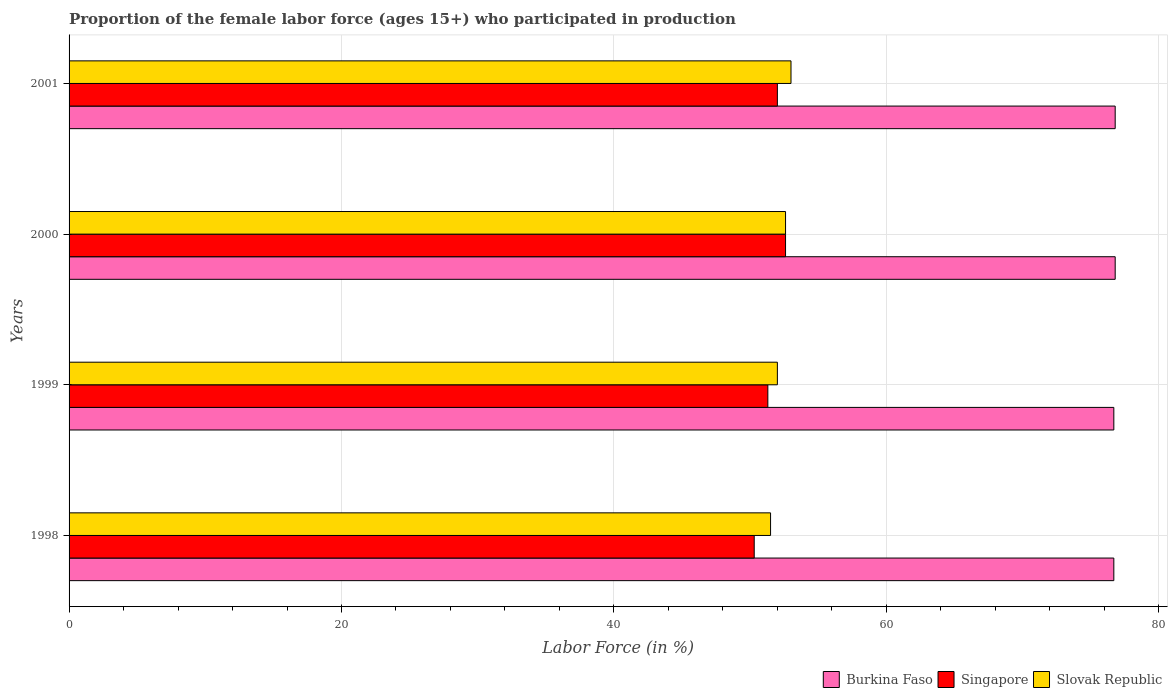How many groups of bars are there?
Your answer should be very brief. 4. Are the number of bars per tick equal to the number of legend labels?
Ensure brevity in your answer.  Yes. Are the number of bars on each tick of the Y-axis equal?
Offer a terse response. Yes. What is the proportion of the female labor force who participated in production in Singapore in 1999?
Provide a succinct answer. 51.3. Across all years, what is the maximum proportion of the female labor force who participated in production in Burkina Faso?
Give a very brief answer. 76.8. Across all years, what is the minimum proportion of the female labor force who participated in production in Singapore?
Ensure brevity in your answer.  50.3. What is the total proportion of the female labor force who participated in production in Singapore in the graph?
Keep it short and to the point. 206.2. What is the difference between the proportion of the female labor force who participated in production in Slovak Republic in 1998 and that in 2000?
Your answer should be compact. -1.1. What is the difference between the proportion of the female labor force who participated in production in Singapore in 2000 and the proportion of the female labor force who participated in production in Burkina Faso in 1999?
Your answer should be very brief. -24.1. What is the average proportion of the female labor force who participated in production in Slovak Republic per year?
Provide a short and direct response. 52.27. In the year 2001, what is the difference between the proportion of the female labor force who participated in production in Slovak Republic and proportion of the female labor force who participated in production in Burkina Faso?
Your response must be concise. -23.8. In how many years, is the proportion of the female labor force who participated in production in Burkina Faso greater than 60 %?
Give a very brief answer. 4. What is the ratio of the proportion of the female labor force who participated in production in Singapore in 2000 to that in 2001?
Ensure brevity in your answer.  1.01. Is the proportion of the female labor force who participated in production in Singapore in 1998 less than that in 2000?
Ensure brevity in your answer.  Yes. Is the difference between the proportion of the female labor force who participated in production in Slovak Republic in 1999 and 2000 greater than the difference between the proportion of the female labor force who participated in production in Burkina Faso in 1999 and 2000?
Provide a short and direct response. No. What is the difference between the highest and the second highest proportion of the female labor force who participated in production in Singapore?
Offer a terse response. 0.6. What is the difference between the highest and the lowest proportion of the female labor force who participated in production in Burkina Faso?
Keep it short and to the point. 0.1. In how many years, is the proportion of the female labor force who participated in production in Singapore greater than the average proportion of the female labor force who participated in production in Singapore taken over all years?
Ensure brevity in your answer.  2. What does the 1st bar from the top in 1998 represents?
Keep it short and to the point. Slovak Republic. What does the 3rd bar from the bottom in 2000 represents?
Offer a terse response. Slovak Republic. How many bars are there?
Your answer should be very brief. 12. Are all the bars in the graph horizontal?
Keep it short and to the point. Yes. What is the difference between two consecutive major ticks on the X-axis?
Your answer should be compact. 20. Are the values on the major ticks of X-axis written in scientific E-notation?
Offer a terse response. No. Does the graph contain any zero values?
Keep it short and to the point. No. Where does the legend appear in the graph?
Offer a very short reply. Bottom right. What is the title of the graph?
Keep it short and to the point. Proportion of the female labor force (ages 15+) who participated in production. Does "Kyrgyz Republic" appear as one of the legend labels in the graph?
Your answer should be compact. No. What is the Labor Force (in %) of Burkina Faso in 1998?
Make the answer very short. 76.7. What is the Labor Force (in %) of Singapore in 1998?
Give a very brief answer. 50.3. What is the Labor Force (in %) in Slovak Republic in 1998?
Your answer should be very brief. 51.5. What is the Labor Force (in %) of Burkina Faso in 1999?
Offer a terse response. 76.7. What is the Labor Force (in %) of Singapore in 1999?
Provide a succinct answer. 51.3. What is the Labor Force (in %) in Burkina Faso in 2000?
Provide a succinct answer. 76.8. What is the Labor Force (in %) of Singapore in 2000?
Give a very brief answer. 52.6. What is the Labor Force (in %) in Slovak Republic in 2000?
Offer a terse response. 52.6. What is the Labor Force (in %) in Burkina Faso in 2001?
Offer a very short reply. 76.8. What is the Labor Force (in %) of Singapore in 2001?
Offer a very short reply. 52. What is the Labor Force (in %) in Slovak Republic in 2001?
Your response must be concise. 53. Across all years, what is the maximum Labor Force (in %) of Burkina Faso?
Offer a very short reply. 76.8. Across all years, what is the maximum Labor Force (in %) in Singapore?
Keep it short and to the point. 52.6. Across all years, what is the maximum Labor Force (in %) in Slovak Republic?
Make the answer very short. 53. Across all years, what is the minimum Labor Force (in %) in Burkina Faso?
Keep it short and to the point. 76.7. Across all years, what is the minimum Labor Force (in %) of Singapore?
Give a very brief answer. 50.3. Across all years, what is the minimum Labor Force (in %) in Slovak Republic?
Your response must be concise. 51.5. What is the total Labor Force (in %) of Burkina Faso in the graph?
Keep it short and to the point. 307. What is the total Labor Force (in %) of Singapore in the graph?
Ensure brevity in your answer.  206.2. What is the total Labor Force (in %) in Slovak Republic in the graph?
Offer a very short reply. 209.1. What is the difference between the Labor Force (in %) in Burkina Faso in 1998 and that in 1999?
Give a very brief answer. 0. What is the difference between the Labor Force (in %) of Singapore in 1998 and that in 1999?
Keep it short and to the point. -1. What is the difference between the Labor Force (in %) in Slovak Republic in 1998 and that in 1999?
Provide a succinct answer. -0.5. What is the difference between the Labor Force (in %) in Burkina Faso in 1998 and that in 2000?
Offer a terse response. -0.1. What is the difference between the Labor Force (in %) in Burkina Faso in 1998 and that in 2001?
Keep it short and to the point. -0.1. What is the difference between the Labor Force (in %) in Singapore in 1998 and that in 2001?
Give a very brief answer. -1.7. What is the difference between the Labor Force (in %) in Burkina Faso in 1999 and that in 2000?
Provide a short and direct response. -0.1. What is the difference between the Labor Force (in %) in Slovak Republic in 1999 and that in 2000?
Provide a short and direct response. -0.6. What is the difference between the Labor Force (in %) in Burkina Faso in 1999 and that in 2001?
Ensure brevity in your answer.  -0.1. What is the difference between the Labor Force (in %) in Singapore in 2000 and that in 2001?
Your response must be concise. 0.6. What is the difference between the Labor Force (in %) in Slovak Republic in 2000 and that in 2001?
Provide a succinct answer. -0.4. What is the difference between the Labor Force (in %) in Burkina Faso in 1998 and the Labor Force (in %) in Singapore in 1999?
Your answer should be compact. 25.4. What is the difference between the Labor Force (in %) in Burkina Faso in 1998 and the Labor Force (in %) in Slovak Republic in 1999?
Make the answer very short. 24.7. What is the difference between the Labor Force (in %) in Singapore in 1998 and the Labor Force (in %) in Slovak Republic in 1999?
Your response must be concise. -1.7. What is the difference between the Labor Force (in %) in Burkina Faso in 1998 and the Labor Force (in %) in Singapore in 2000?
Provide a succinct answer. 24.1. What is the difference between the Labor Force (in %) in Burkina Faso in 1998 and the Labor Force (in %) in Slovak Republic in 2000?
Ensure brevity in your answer.  24.1. What is the difference between the Labor Force (in %) of Singapore in 1998 and the Labor Force (in %) of Slovak Republic in 2000?
Offer a terse response. -2.3. What is the difference between the Labor Force (in %) in Burkina Faso in 1998 and the Labor Force (in %) in Singapore in 2001?
Provide a short and direct response. 24.7. What is the difference between the Labor Force (in %) of Burkina Faso in 1998 and the Labor Force (in %) of Slovak Republic in 2001?
Your answer should be compact. 23.7. What is the difference between the Labor Force (in %) in Burkina Faso in 1999 and the Labor Force (in %) in Singapore in 2000?
Ensure brevity in your answer.  24.1. What is the difference between the Labor Force (in %) in Burkina Faso in 1999 and the Labor Force (in %) in Slovak Republic in 2000?
Keep it short and to the point. 24.1. What is the difference between the Labor Force (in %) of Singapore in 1999 and the Labor Force (in %) of Slovak Republic in 2000?
Make the answer very short. -1.3. What is the difference between the Labor Force (in %) of Burkina Faso in 1999 and the Labor Force (in %) of Singapore in 2001?
Make the answer very short. 24.7. What is the difference between the Labor Force (in %) of Burkina Faso in 1999 and the Labor Force (in %) of Slovak Republic in 2001?
Make the answer very short. 23.7. What is the difference between the Labor Force (in %) in Singapore in 1999 and the Labor Force (in %) in Slovak Republic in 2001?
Provide a succinct answer. -1.7. What is the difference between the Labor Force (in %) in Burkina Faso in 2000 and the Labor Force (in %) in Singapore in 2001?
Give a very brief answer. 24.8. What is the difference between the Labor Force (in %) in Burkina Faso in 2000 and the Labor Force (in %) in Slovak Republic in 2001?
Make the answer very short. 23.8. What is the average Labor Force (in %) in Burkina Faso per year?
Your answer should be compact. 76.75. What is the average Labor Force (in %) of Singapore per year?
Your answer should be compact. 51.55. What is the average Labor Force (in %) in Slovak Republic per year?
Offer a very short reply. 52.27. In the year 1998, what is the difference between the Labor Force (in %) in Burkina Faso and Labor Force (in %) in Singapore?
Your answer should be compact. 26.4. In the year 1998, what is the difference between the Labor Force (in %) of Burkina Faso and Labor Force (in %) of Slovak Republic?
Provide a succinct answer. 25.2. In the year 1999, what is the difference between the Labor Force (in %) of Burkina Faso and Labor Force (in %) of Singapore?
Provide a succinct answer. 25.4. In the year 1999, what is the difference between the Labor Force (in %) of Burkina Faso and Labor Force (in %) of Slovak Republic?
Ensure brevity in your answer.  24.7. In the year 1999, what is the difference between the Labor Force (in %) of Singapore and Labor Force (in %) of Slovak Republic?
Give a very brief answer. -0.7. In the year 2000, what is the difference between the Labor Force (in %) of Burkina Faso and Labor Force (in %) of Singapore?
Ensure brevity in your answer.  24.2. In the year 2000, what is the difference between the Labor Force (in %) of Burkina Faso and Labor Force (in %) of Slovak Republic?
Offer a very short reply. 24.2. In the year 2001, what is the difference between the Labor Force (in %) in Burkina Faso and Labor Force (in %) in Singapore?
Provide a succinct answer. 24.8. In the year 2001, what is the difference between the Labor Force (in %) in Burkina Faso and Labor Force (in %) in Slovak Republic?
Offer a terse response. 23.8. What is the ratio of the Labor Force (in %) in Singapore in 1998 to that in 1999?
Offer a very short reply. 0.98. What is the ratio of the Labor Force (in %) in Slovak Republic in 1998 to that in 1999?
Ensure brevity in your answer.  0.99. What is the ratio of the Labor Force (in %) in Singapore in 1998 to that in 2000?
Give a very brief answer. 0.96. What is the ratio of the Labor Force (in %) of Slovak Republic in 1998 to that in 2000?
Make the answer very short. 0.98. What is the ratio of the Labor Force (in %) of Burkina Faso in 1998 to that in 2001?
Offer a terse response. 1. What is the ratio of the Labor Force (in %) of Singapore in 1998 to that in 2001?
Offer a terse response. 0.97. What is the ratio of the Labor Force (in %) in Slovak Republic in 1998 to that in 2001?
Keep it short and to the point. 0.97. What is the ratio of the Labor Force (in %) of Singapore in 1999 to that in 2000?
Make the answer very short. 0.98. What is the ratio of the Labor Force (in %) in Burkina Faso in 1999 to that in 2001?
Your answer should be compact. 1. What is the ratio of the Labor Force (in %) of Singapore in 1999 to that in 2001?
Provide a succinct answer. 0.99. What is the ratio of the Labor Force (in %) in Slovak Republic in 1999 to that in 2001?
Provide a short and direct response. 0.98. What is the ratio of the Labor Force (in %) of Singapore in 2000 to that in 2001?
Provide a succinct answer. 1.01. What is the ratio of the Labor Force (in %) in Slovak Republic in 2000 to that in 2001?
Provide a succinct answer. 0.99. What is the difference between the highest and the second highest Labor Force (in %) of Burkina Faso?
Ensure brevity in your answer.  0. What is the difference between the highest and the second highest Labor Force (in %) of Singapore?
Provide a short and direct response. 0.6. What is the difference between the highest and the second highest Labor Force (in %) of Slovak Republic?
Ensure brevity in your answer.  0.4. 